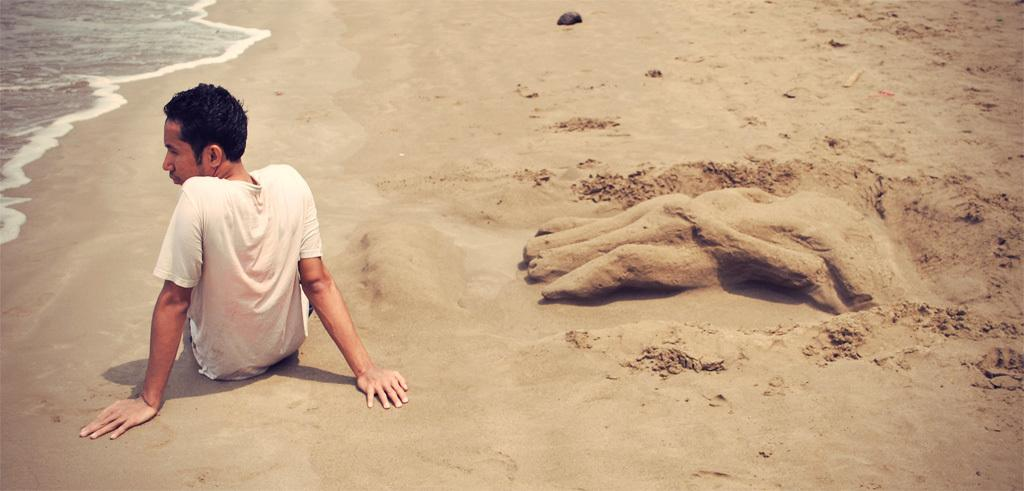What is the person in the image doing? The person is sitting on the sand. What can be seen in the sand in the image? There is a sand art in the image. What is visible in the background of the image? There is water visible in the image. How many sheep are present in the sand art in the image? There are no sheep present in the sand art or the image. 